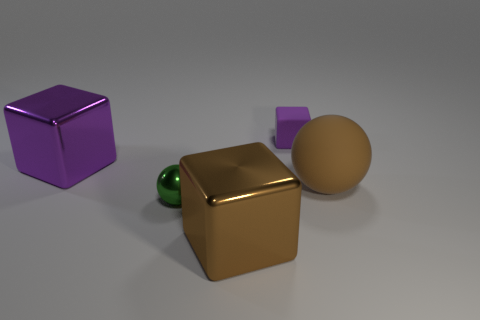Add 2 cubes. How many objects exist? 7 Subtract all spheres. How many objects are left? 3 Add 5 tiny rubber blocks. How many tiny rubber blocks are left? 6 Add 3 small red rubber balls. How many small red rubber balls exist? 3 Subtract 0 blue balls. How many objects are left? 5 Subtract all purple rubber cubes. Subtract all tiny green metallic spheres. How many objects are left? 3 